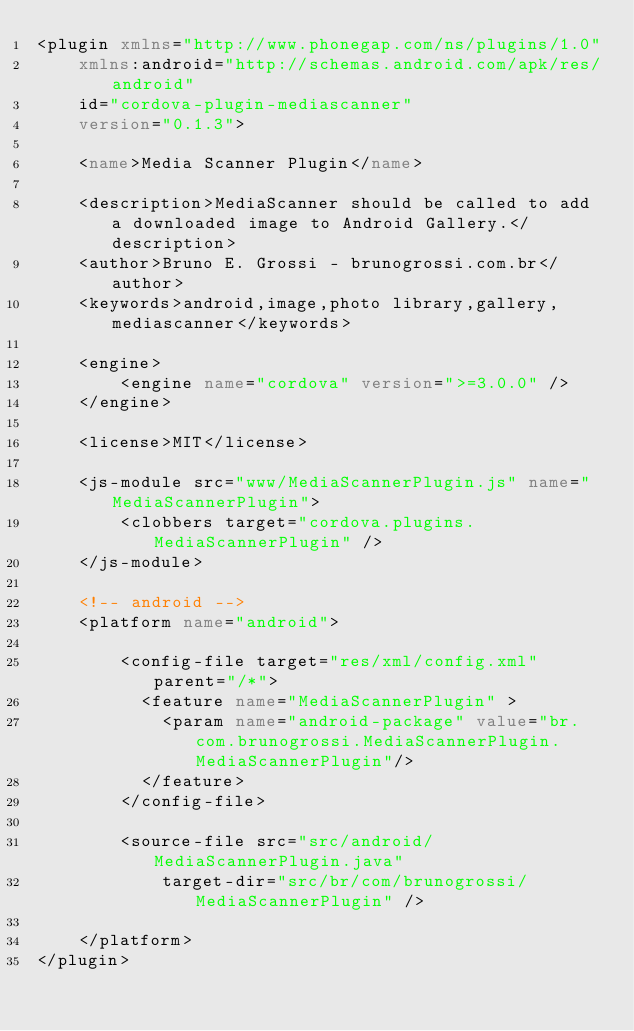Convert code to text. <code><loc_0><loc_0><loc_500><loc_500><_XML_><plugin xmlns="http://www.phonegap.com/ns/plugins/1.0"
    xmlns:android="http://schemas.android.com/apk/res/android"
    id="cordova-plugin-mediascanner"
    version="0.1.3">

    <name>Media Scanner Plugin</name>

    <description>MediaScanner should be called to add a downloaded image to Android Gallery.</description>
    <author>Bruno E. Grossi - brunogrossi.com.br</author>
    <keywords>android,image,photo library,gallery,mediascanner</keywords>

    <engine>
        <engine name="cordova" version=">=3.0.0" />
    </engine>

    <license>MIT</license>

    <js-module src="www/MediaScannerPlugin.js" name="MediaScannerPlugin">
        <clobbers target="cordova.plugins.MediaScannerPlugin" />
    </js-module>

    <!-- android -->
    <platform name="android">

        <config-file target="res/xml/config.xml" parent="/*">
          <feature name="MediaScannerPlugin" >
            <param name="android-package" value="br.com.brunogrossi.MediaScannerPlugin.MediaScannerPlugin"/>
          </feature>
        </config-file>

        <source-file src="src/android/MediaScannerPlugin.java"
            target-dir="src/br/com/brunogrossi/MediaScannerPlugin" />

    </platform>
</plugin>
</code> 